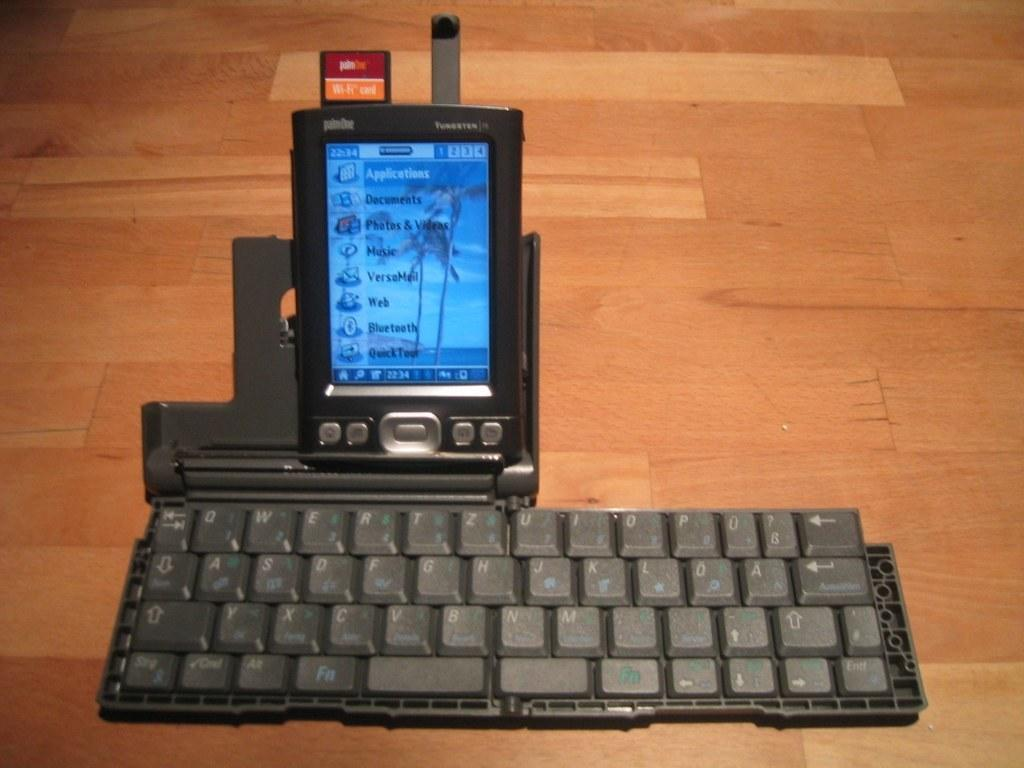<image>
Relay a brief, clear account of the picture shown. A smart phone jacked into a keyboard open to a page that says applications at the top. 